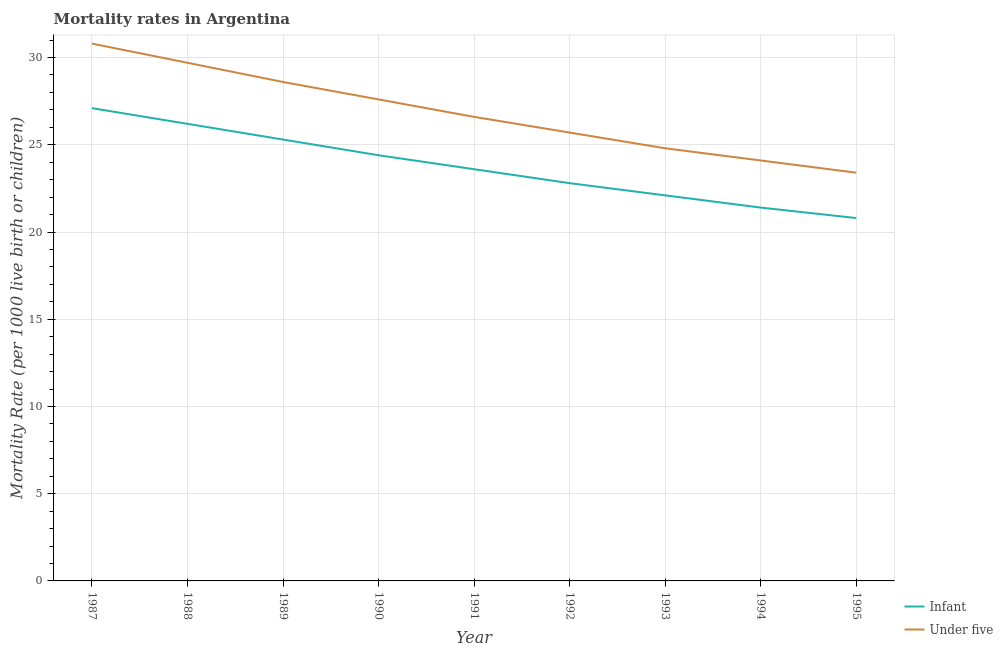How many different coloured lines are there?
Provide a succinct answer. 2. Does the line corresponding to infant mortality rate intersect with the line corresponding to under-5 mortality rate?
Give a very brief answer. No. Is the number of lines equal to the number of legend labels?
Your response must be concise. Yes. What is the under-5 mortality rate in 1991?
Your response must be concise. 26.6. Across all years, what is the maximum under-5 mortality rate?
Ensure brevity in your answer.  30.8. Across all years, what is the minimum under-5 mortality rate?
Your answer should be very brief. 23.4. In which year was the infant mortality rate maximum?
Offer a terse response. 1987. What is the total infant mortality rate in the graph?
Make the answer very short. 213.7. What is the difference between the under-5 mortality rate in 1989 and that in 1992?
Provide a short and direct response. 2.9. What is the difference between the infant mortality rate in 1988 and the under-5 mortality rate in 1990?
Give a very brief answer. -1.4. What is the average under-5 mortality rate per year?
Offer a terse response. 26.81. What is the ratio of the under-5 mortality rate in 1987 to that in 1993?
Ensure brevity in your answer.  1.24. What is the difference between the highest and the second highest under-5 mortality rate?
Provide a short and direct response. 1.1. What is the difference between the highest and the lowest infant mortality rate?
Make the answer very short. 6.3. In how many years, is the under-5 mortality rate greater than the average under-5 mortality rate taken over all years?
Give a very brief answer. 4. Is the sum of the under-5 mortality rate in 1989 and 1993 greater than the maximum infant mortality rate across all years?
Your response must be concise. Yes. Does the infant mortality rate monotonically increase over the years?
Ensure brevity in your answer.  No. How many years are there in the graph?
Provide a succinct answer. 9. Are the values on the major ticks of Y-axis written in scientific E-notation?
Offer a very short reply. No. Does the graph contain any zero values?
Provide a short and direct response. No. What is the title of the graph?
Provide a succinct answer. Mortality rates in Argentina. Does "Not attending school" appear as one of the legend labels in the graph?
Provide a succinct answer. No. What is the label or title of the X-axis?
Provide a short and direct response. Year. What is the label or title of the Y-axis?
Your answer should be compact. Mortality Rate (per 1000 live birth or children). What is the Mortality Rate (per 1000 live birth or children) of Infant in 1987?
Give a very brief answer. 27.1. What is the Mortality Rate (per 1000 live birth or children) in Under five in 1987?
Provide a succinct answer. 30.8. What is the Mortality Rate (per 1000 live birth or children) in Infant in 1988?
Offer a very short reply. 26.2. What is the Mortality Rate (per 1000 live birth or children) in Under five in 1988?
Your answer should be very brief. 29.7. What is the Mortality Rate (per 1000 live birth or children) of Infant in 1989?
Ensure brevity in your answer.  25.3. What is the Mortality Rate (per 1000 live birth or children) of Under five in 1989?
Keep it short and to the point. 28.6. What is the Mortality Rate (per 1000 live birth or children) in Infant in 1990?
Your response must be concise. 24.4. What is the Mortality Rate (per 1000 live birth or children) of Under five in 1990?
Offer a very short reply. 27.6. What is the Mortality Rate (per 1000 live birth or children) in Infant in 1991?
Ensure brevity in your answer.  23.6. What is the Mortality Rate (per 1000 live birth or children) of Under five in 1991?
Keep it short and to the point. 26.6. What is the Mortality Rate (per 1000 live birth or children) in Infant in 1992?
Ensure brevity in your answer.  22.8. What is the Mortality Rate (per 1000 live birth or children) of Under five in 1992?
Give a very brief answer. 25.7. What is the Mortality Rate (per 1000 live birth or children) of Infant in 1993?
Provide a short and direct response. 22.1. What is the Mortality Rate (per 1000 live birth or children) of Under five in 1993?
Keep it short and to the point. 24.8. What is the Mortality Rate (per 1000 live birth or children) of Infant in 1994?
Ensure brevity in your answer.  21.4. What is the Mortality Rate (per 1000 live birth or children) of Under five in 1994?
Offer a terse response. 24.1. What is the Mortality Rate (per 1000 live birth or children) of Infant in 1995?
Provide a succinct answer. 20.8. What is the Mortality Rate (per 1000 live birth or children) of Under five in 1995?
Your answer should be compact. 23.4. Across all years, what is the maximum Mortality Rate (per 1000 live birth or children) in Infant?
Make the answer very short. 27.1. Across all years, what is the maximum Mortality Rate (per 1000 live birth or children) of Under five?
Ensure brevity in your answer.  30.8. Across all years, what is the minimum Mortality Rate (per 1000 live birth or children) of Infant?
Your answer should be compact. 20.8. Across all years, what is the minimum Mortality Rate (per 1000 live birth or children) of Under five?
Make the answer very short. 23.4. What is the total Mortality Rate (per 1000 live birth or children) of Infant in the graph?
Your answer should be compact. 213.7. What is the total Mortality Rate (per 1000 live birth or children) in Under five in the graph?
Give a very brief answer. 241.3. What is the difference between the Mortality Rate (per 1000 live birth or children) in Under five in 1987 and that in 1989?
Provide a short and direct response. 2.2. What is the difference between the Mortality Rate (per 1000 live birth or children) in Infant in 1987 and that in 1991?
Your answer should be very brief. 3.5. What is the difference between the Mortality Rate (per 1000 live birth or children) in Under five in 1987 and that in 1991?
Ensure brevity in your answer.  4.2. What is the difference between the Mortality Rate (per 1000 live birth or children) of Infant in 1987 and that in 1992?
Your answer should be compact. 4.3. What is the difference between the Mortality Rate (per 1000 live birth or children) of Under five in 1987 and that in 1994?
Ensure brevity in your answer.  6.7. What is the difference between the Mortality Rate (per 1000 live birth or children) in Infant in 1988 and that in 1989?
Keep it short and to the point. 0.9. What is the difference between the Mortality Rate (per 1000 live birth or children) of Under five in 1988 and that in 1989?
Provide a succinct answer. 1.1. What is the difference between the Mortality Rate (per 1000 live birth or children) in Infant in 1988 and that in 1990?
Offer a terse response. 1.8. What is the difference between the Mortality Rate (per 1000 live birth or children) in Under five in 1988 and that in 1990?
Provide a succinct answer. 2.1. What is the difference between the Mortality Rate (per 1000 live birth or children) of Infant in 1988 and that in 1991?
Provide a short and direct response. 2.6. What is the difference between the Mortality Rate (per 1000 live birth or children) of Infant in 1988 and that in 1992?
Give a very brief answer. 3.4. What is the difference between the Mortality Rate (per 1000 live birth or children) of Under five in 1989 and that in 1990?
Make the answer very short. 1. What is the difference between the Mortality Rate (per 1000 live birth or children) in Under five in 1989 and that in 1993?
Make the answer very short. 3.8. What is the difference between the Mortality Rate (per 1000 live birth or children) in Under five in 1989 and that in 1994?
Your answer should be very brief. 4.5. What is the difference between the Mortality Rate (per 1000 live birth or children) in Infant in 1989 and that in 1995?
Your response must be concise. 4.5. What is the difference between the Mortality Rate (per 1000 live birth or children) of Under five in 1989 and that in 1995?
Keep it short and to the point. 5.2. What is the difference between the Mortality Rate (per 1000 live birth or children) in Infant in 1990 and that in 1991?
Your response must be concise. 0.8. What is the difference between the Mortality Rate (per 1000 live birth or children) in Under five in 1990 and that in 1991?
Keep it short and to the point. 1. What is the difference between the Mortality Rate (per 1000 live birth or children) of Infant in 1990 and that in 1992?
Make the answer very short. 1.6. What is the difference between the Mortality Rate (per 1000 live birth or children) of Under five in 1990 and that in 1992?
Provide a short and direct response. 1.9. What is the difference between the Mortality Rate (per 1000 live birth or children) of Under five in 1990 and that in 1993?
Offer a very short reply. 2.8. What is the difference between the Mortality Rate (per 1000 live birth or children) of Under five in 1990 and that in 1994?
Keep it short and to the point. 3.5. What is the difference between the Mortality Rate (per 1000 live birth or children) in Infant in 1990 and that in 1995?
Make the answer very short. 3.6. What is the difference between the Mortality Rate (per 1000 live birth or children) of Under five in 1991 and that in 1992?
Offer a terse response. 0.9. What is the difference between the Mortality Rate (per 1000 live birth or children) of Under five in 1991 and that in 1993?
Offer a very short reply. 1.8. What is the difference between the Mortality Rate (per 1000 live birth or children) of Under five in 1991 and that in 1994?
Give a very brief answer. 2.5. What is the difference between the Mortality Rate (per 1000 live birth or children) in Infant in 1991 and that in 1995?
Ensure brevity in your answer.  2.8. What is the difference between the Mortality Rate (per 1000 live birth or children) in Infant in 1992 and that in 1993?
Your answer should be compact. 0.7. What is the difference between the Mortality Rate (per 1000 live birth or children) of Under five in 1992 and that in 1993?
Make the answer very short. 0.9. What is the difference between the Mortality Rate (per 1000 live birth or children) of Under five in 1992 and that in 1994?
Your answer should be very brief. 1.6. What is the difference between the Mortality Rate (per 1000 live birth or children) of Under five in 1992 and that in 1995?
Make the answer very short. 2.3. What is the difference between the Mortality Rate (per 1000 live birth or children) in Infant in 1993 and that in 1995?
Offer a terse response. 1.3. What is the difference between the Mortality Rate (per 1000 live birth or children) in Under five in 1993 and that in 1995?
Provide a short and direct response. 1.4. What is the difference between the Mortality Rate (per 1000 live birth or children) in Infant in 1994 and that in 1995?
Your answer should be compact. 0.6. What is the difference between the Mortality Rate (per 1000 live birth or children) in Under five in 1994 and that in 1995?
Your answer should be compact. 0.7. What is the difference between the Mortality Rate (per 1000 live birth or children) in Infant in 1987 and the Mortality Rate (per 1000 live birth or children) in Under five in 1989?
Provide a succinct answer. -1.5. What is the difference between the Mortality Rate (per 1000 live birth or children) in Infant in 1987 and the Mortality Rate (per 1000 live birth or children) in Under five in 1990?
Your answer should be very brief. -0.5. What is the difference between the Mortality Rate (per 1000 live birth or children) in Infant in 1987 and the Mortality Rate (per 1000 live birth or children) in Under five in 1994?
Give a very brief answer. 3. What is the difference between the Mortality Rate (per 1000 live birth or children) in Infant in 1988 and the Mortality Rate (per 1000 live birth or children) in Under five in 1990?
Give a very brief answer. -1.4. What is the difference between the Mortality Rate (per 1000 live birth or children) in Infant in 1988 and the Mortality Rate (per 1000 live birth or children) in Under five in 1992?
Your response must be concise. 0.5. What is the difference between the Mortality Rate (per 1000 live birth or children) of Infant in 1988 and the Mortality Rate (per 1000 live birth or children) of Under five in 1995?
Give a very brief answer. 2.8. What is the difference between the Mortality Rate (per 1000 live birth or children) of Infant in 1989 and the Mortality Rate (per 1000 live birth or children) of Under five in 1990?
Give a very brief answer. -2.3. What is the difference between the Mortality Rate (per 1000 live birth or children) of Infant in 1989 and the Mortality Rate (per 1000 live birth or children) of Under five in 1991?
Make the answer very short. -1.3. What is the difference between the Mortality Rate (per 1000 live birth or children) of Infant in 1989 and the Mortality Rate (per 1000 live birth or children) of Under five in 1992?
Provide a short and direct response. -0.4. What is the difference between the Mortality Rate (per 1000 live birth or children) of Infant in 1989 and the Mortality Rate (per 1000 live birth or children) of Under five in 1995?
Offer a terse response. 1.9. What is the difference between the Mortality Rate (per 1000 live birth or children) in Infant in 1990 and the Mortality Rate (per 1000 live birth or children) in Under five in 1992?
Give a very brief answer. -1.3. What is the difference between the Mortality Rate (per 1000 live birth or children) in Infant in 1990 and the Mortality Rate (per 1000 live birth or children) in Under five in 1993?
Provide a short and direct response. -0.4. What is the difference between the Mortality Rate (per 1000 live birth or children) of Infant in 1990 and the Mortality Rate (per 1000 live birth or children) of Under five in 1994?
Provide a succinct answer. 0.3. What is the difference between the Mortality Rate (per 1000 live birth or children) in Infant in 1991 and the Mortality Rate (per 1000 live birth or children) in Under five in 1992?
Offer a very short reply. -2.1. What is the difference between the Mortality Rate (per 1000 live birth or children) of Infant in 1991 and the Mortality Rate (per 1000 live birth or children) of Under five in 1994?
Keep it short and to the point. -0.5. What is the difference between the Mortality Rate (per 1000 live birth or children) of Infant in 1991 and the Mortality Rate (per 1000 live birth or children) of Under five in 1995?
Provide a short and direct response. 0.2. What is the difference between the Mortality Rate (per 1000 live birth or children) of Infant in 1992 and the Mortality Rate (per 1000 live birth or children) of Under five in 1993?
Give a very brief answer. -2. What is the difference between the Mortality Rate (per 1000 live birth or children) in Infant in 1992 and the Mortality Rate (per 1000 live birth or children) in Under five in 1995?
Your answer should be compact. -0.6. What is the difference between the Mortality Rate (per 1000 live birth or children) of Infant in 1993 and the Mortality Rate (per 1000 live birth or children) of Under five in 1994?
Ensure brevity in your answer.  -2. What is the difference between the Mortality Rate (per 1000 live birth or children) of Infant in 1994 and the Mortality Rate (per 1000 live birth or children) of Under five in 1995?
Ensure brevity in your answer.  -2. What is the average Mortality Rate (per 1000 live birth or children) in Infant per year?
Provide a short and direct response. 23.74. What is the average Mortality Rate (per 1000 live birth or children) of Under five per year?
Provide a succinct answer. 26.81. In the year 1987, what is the difference between the Mortality Rate (per 1000 live birth or children) in Infant and Mortality Rate (per 1000 live birth or children) in Under five?
Provide a succinct answer. -3.7. In the year 1989, what is the difference between the Mortality Rate (per 1000 live birth or children) in Infant and Mortality Rate (per 1000 live birth or children) in Under five?
Your answer should be compact. -3.3. In the year 1990, what is the difference between the Mortality Rate (per 1000 live birth or children) of Infant and Mortality Rate (per 1000 live birth or children) of Under five?
Make the answer very short. -3.2. In the year 1991, what is the difference between the Mortality Rate (per 1000 live birth or children) of Infant and Mortality Rate (per 1000 live birth or children) of Under five?
Your answer should be very brief. -3. In the year 1992, what is the difference between the Mortality Rate (per 1000 live birth or children) of Infant and Mortality Rate (per 1000 live birth or children) of Under five?
Offer a very short reply. -2.9. In the year 1993, what is the difference between the Mortality Rate (per 1000 live birth or children) of Infant and Mortality Rate (per 1000 live birth or children) of Under five?
Keep it short and to the point. -2.7. In the year 1994, what is the difference between the Mortality Rate (per 1000 live birth or children) in Infant and Mortality Rate (per 1000 live birth or children) in Under five?
Offer a very short reply. -2.7. In the year 1995, what is the difference between the Mortality Rate (per 1000 live birth or children) of Infant and Mortality Rate (per 1000 live birth or children) of Under five?
Your answer should be very brief. -2.6. What is the ratio of the Mortality Rate (per 1000 live birth or children) in Infant in 1987 to that in 1988?
Keep it short and to the point. 1.03. What is the ratio of the Mortality Rate (per 1000 live birth or children) in Under five in 1987 to that in 1988?
Your response must be concise. 1.04. What is the ratio of the Mortality Rate (per 1000 live birth or children) in Infant in 1987 to that in 1989?
Provide a succinct answer. 1.07. What is the ratio of the Mortality Rate (per 1000 live birth or children) in Under five in 1987 to that in 1989?
Offer a terse response. 1.08. What is the ratio of the Mortality Rate (per 1000 live birth or children) in Infant in 1987 to that in 1990?
Make the answer very short. 1.11. What is the ratio of the Mortality Rate (per 1000 live birth or children) of Under five in 1987 to that in 1990?
Keep it short and to the point. 1.12. What is the ratio of the Mortality Rate (per 1000 live birth or children) in Infant in 1987 to that in 1991?
Your answer should be very brief. 1.15. What is the ratio of the Mortality Rate (per 1000 live birth or children) in Under five in 1987 to that in 1991?
Your answer should be very brief. 1.16. What is the ratio of the Mortality Rate (per 1000 live birth or children) of Infant in 1987 to that in 1992?
Make the answer very short. 1.19. What is the ratio of the Mortality Rate (per 1000 live birth or children) of Under five in 1987 to that in 1992?
Provide a succinct answer. 1.2. What is the ratio of the Mortality Rate (per 1000 live birth or children) in Infant in 1987 to that in 1993?
Provide a short and direct response. 1.23. What is the ratio of the Mortality Rate (per 1000 live birth or children) in Under five in 1987 to that in 1993?
Your answer should be compact. 1.24. What is the ratio of the Mortality Rate (per 1000 live birth or children) of Infant in 1987 to that in 1994?
Your answer should be compact. 1.27. What is the ratio of the Mortality Rate (per 1000 live birth or children) of Under five in 1987 to that in 1994?
Provide a succinct answer. 1.28. What is the ratio of the Mortality Rate (per 1000 live birth or children) in Infant in 1987 to that in 1995?
Provide a succinct answer. 1.3. What is the ratio of the Mortality Rate (per 1000 live birth or children) of Under five in 1987 to that in 1995?
Offer a terse response. 1.32. What is the ratio of the Mortality Rate (per 1000 live birth or children) of Infant in 1988 to that in 1989?
Give a very brief answer. 1.04. What is the ratio of the Mortality Rate (per 1000 live birth or children) in Infant in 1988 to that in 1990?
Your answer should be very brief. 1.07. What is the ratio of the Mortality Rate (per 1000 live birth or children) of Under five in 1988 to that in 1990?
Keep it short and to the point. 1.08. What is the ratio of the Mortality Rate (per 1000 live birth or children) of Infant in 1988 to that in 1991?
Provide a short and direct response. 1.11. What is the ratio of the Mortality Rate (per 1000 live birth or children) of Under five in 1988 to that in 1991?
Offer a very short reply. 1.12. What is the ratio of the Mortality Rate (per 1000 live birth or children) in Infant in 1988 to that in 1992?
Your response must be concise. 1.15. What is the ratio of the Mortality Rate (per 1000 live birth or children) in Under five in 1988 to that in 1992?
Make the answer very short. 1.16. What is the ratio of the Mortality Rate (per 1000 live birth or children) in Infant in 1988 to that in 1993?
Keep it short and to the point. 1.19. What is the ratio of the Mortality Rate (per 1000 live birth or children) of Under five in 1988 to that in 1993?
Your answer should be compact. 1.2. What is the ratio of the Mortality Rate (per 1000 live birth or children) in Infant in 1988 to that in 1994?
Your answer should be compact. 1.22. What is the ratio of the Mortality Rate (per 1000 live birth or children) in Under five in 1988 to that in 1994?
Your response must be concise. 1.23. What is the ratio of the Mortality Rate (per 1000 live birth or children) of Infant in 1988 to that in 1995?
Provide a succinct answer. 1.26. What is the ratio of the Mortality Rate (per 1000 live birth or children) of Under five in 1988 to that in 1995?
Ensure brevity in your answer.  1.27. What is the ratio of the Mortality Rate (per 1000 live birth or children) of Infant in 1989 to that in 1990?
Offer a very short reply. 1.04. What is the ratio of the Mortality Rate (per 1000 live birth or children) in Under five in 1989 to that in 1990?
Make the answer very short. 1.04. What is the ratio of the Mortality Rate (per 1000 live birth or children) in Infant in 1989 to that in 1991?
Offer a very short reply. 1.07. What is the ratio of the Mortality Rate (per 1000 live birth or children) in Under five in 1989 to that in 1991?
Your answer should be very brief. 1.08. What is the ratio of the Mortality Rate (per 1000 live birth or children) of Infant in 1989 to that in 1992?
Your answer should be compact. 1.11. What is the ratio of the Mortality Rate (per 1000 live birth or children) of Under five in 1989 to that in 1992?
Offer a terse response. 1.11. What is the ratio of the Mortality Rate (per 1000 live birth or children) in Infant in 1989 to that in 1993?
Ensure brevity in your answer.  1.14. What is the ratio of the Mortality Rate (per 1000 live birth or children) of Under five in 1989 to that in 1993?
Your response must be concise. 1.15. What is the ratio of the Mortality Rate (per 1000 live birth or children) in Infant in 1989 to that in 1994?
Give a very brief answer. 1.18. What is the ratio of the Mortality Rate (per 1000 live birth or children) in Under five in 1989 to that in 1994?
Provide a succinct answer. 1.19. What is the ratio of the Mortality Rate (per 1000 live birth or children) in Infant in 1989 to that in 1995?
Give a very brief answer. 1.22. What is the ratio of the Mortality Rate (per 1000 live birth or children) of Under five in 1989 to that in 1995?
Your answer should be compact. 1.22. What is the ratio of the Mortality Rate (per 1000 live birth or children) of Infant in 1990 to that in 1991?
Make the answer very short. 1.03. What is the ratio of the Mortality Rate (per 1000 live birth or children) of Under five in 1990 to that in 1991?
Provide a succinct answer. 1.04. What is the ratio of the Mortality Rate (per 1000 live birth or children) of Infant in 1990 to that in 1992?
Your answer should be very brief. 1.07. What is the ratio of the Mortality Rate (per 1000 live birth or children) of Under five in 1990 to that in 1992?
Offer a very short reply. 1.07. What is the ratio of the Mortality Rate (per 1000 live birth or children) of Infant in 1990 to that in 1993?
Provide a succinct answer. 1.1. What is the ratio of the Mortality Rate (per 1000 live birth or children) of Under five in 1990 to that in 1993?
Your answer should be compact. 1.11. What is the ratio of the Mortality Rate (per 1000 live birth or children) of Infant in 1990 to that in 1994?
Give a very brief answer. 1.14. What is the ratio of the Mortality Rate (per 1000 live birth or children) of Under five in 1990 to that in 1994?
Keep it short and to the point. 1.15. What is the ratio of the Mortality Rate (per 1000 live birth or children) of Infant in 1990 to that in 1995?
Ensure brevity in your answer.  1.17. What is the ratio of the Mortality Rate (per 1000 live birth or children) in Under five in 1990 to that in 1995?
Your answer should be very brief. 1.18. What is the ratio of the Mortality Rate (per 1000 live birth or children) in Infant in 1991 to that in 1992?
Keep it short and to the point. 1.04. What is the ratio of the Mortality Rate (per 1000 live birth or children) in Under five in 1991 to that in 1992?
Provide a short and direct response. 1.03. What is the ratio of the Mortality Rate (per 1000 live birth or children) of Infant in 1991 to that in 1993?
Give a very brief answer. 1.07. What is the ratio of the Mortality Rate (per 1000 live birth or children) of Under five in 1991 to that in 1993?
Offer a terse response. 1.07. What is the ratio of the Mortality Rate (per 1000 live birth or children) in Infant in 1991 to that in 1994?
Offer a terse response. 1.1. What is the ratio of the Mortality Rate (per 1000 live birth or children) of Under five in 1991 to that in 1994?
Your response must be concise. 1.1. What is the ratio of the Mortality Rate (per 1000 live birth or children) in Infant in 1991 to that in 1995?
Your answer should be very brief. 1.13. What is the ratio of the Mortality Rate (per 1000 live birth or children) in Under five in 1991 to that in 1995?
Ensure brevity in your answer.  1.14. What is the ratio of the Mortality Rate (per 1000 live birth or children) of Infant in 1992 to that in 1993?
Offer a very short reply. 1.03. What is the ratio of the Mortality Rate (per 1000 live birth or children) in Under five in 1992 to that in 1993?
Provide a short and direct response. 1.04. What is the ratio of the Mortality Rate (per 1000 live birth or children) in Infant in 1992 to that in 1994?
Provide a succinct answer. 1.07. What is the ratio of the Mortality Rate (per 1000 live birth or children) in Under five in 1992 to that in 1994?
Make the answer very short. 1.07. What is the ratio of the Mortality Rate (per 1000 live birth or children) in Infant in 1992 to that in 1995?
Give a very brief answer. 1.1. What is the ratio of the Mortality Rate (per 1000 live birth or children) of Under five in 1992 to that in 1995?
Give a very brief answer. 1.1. What is the ratio of the Mortality Rate (per 1000 live birth or children) of Infant in 1993 to that in 1994?
Your answer should be very brief. 1.03. What is the ratio of the Mortality Rate (per 1000 live birth or children) in Infant in 1993 to that in 1995?
Offer a terse response. 1.06. What is the ratio of the Mortality Rate (per 1000 live birth or children) of Under five in 1993 to that in 1995?
Give a very brief answer. 1.06. What is the ratio of the Mortality Rate (per 1000 live birth or children) of Infant in 1994 to that in 1995?
Your answer should be very brief. 1.03. What is the ratio of the Mortality Rate (per 1000 live birth or children) of Under five in 1994 to that in 1995?
Ensure brevity in your answer.  1.03. What is the difference between the highest and the lowest Mortality Rate (per 1000 live birth or children) in Under five?
Ensure brevity in your answer.  7.4. 